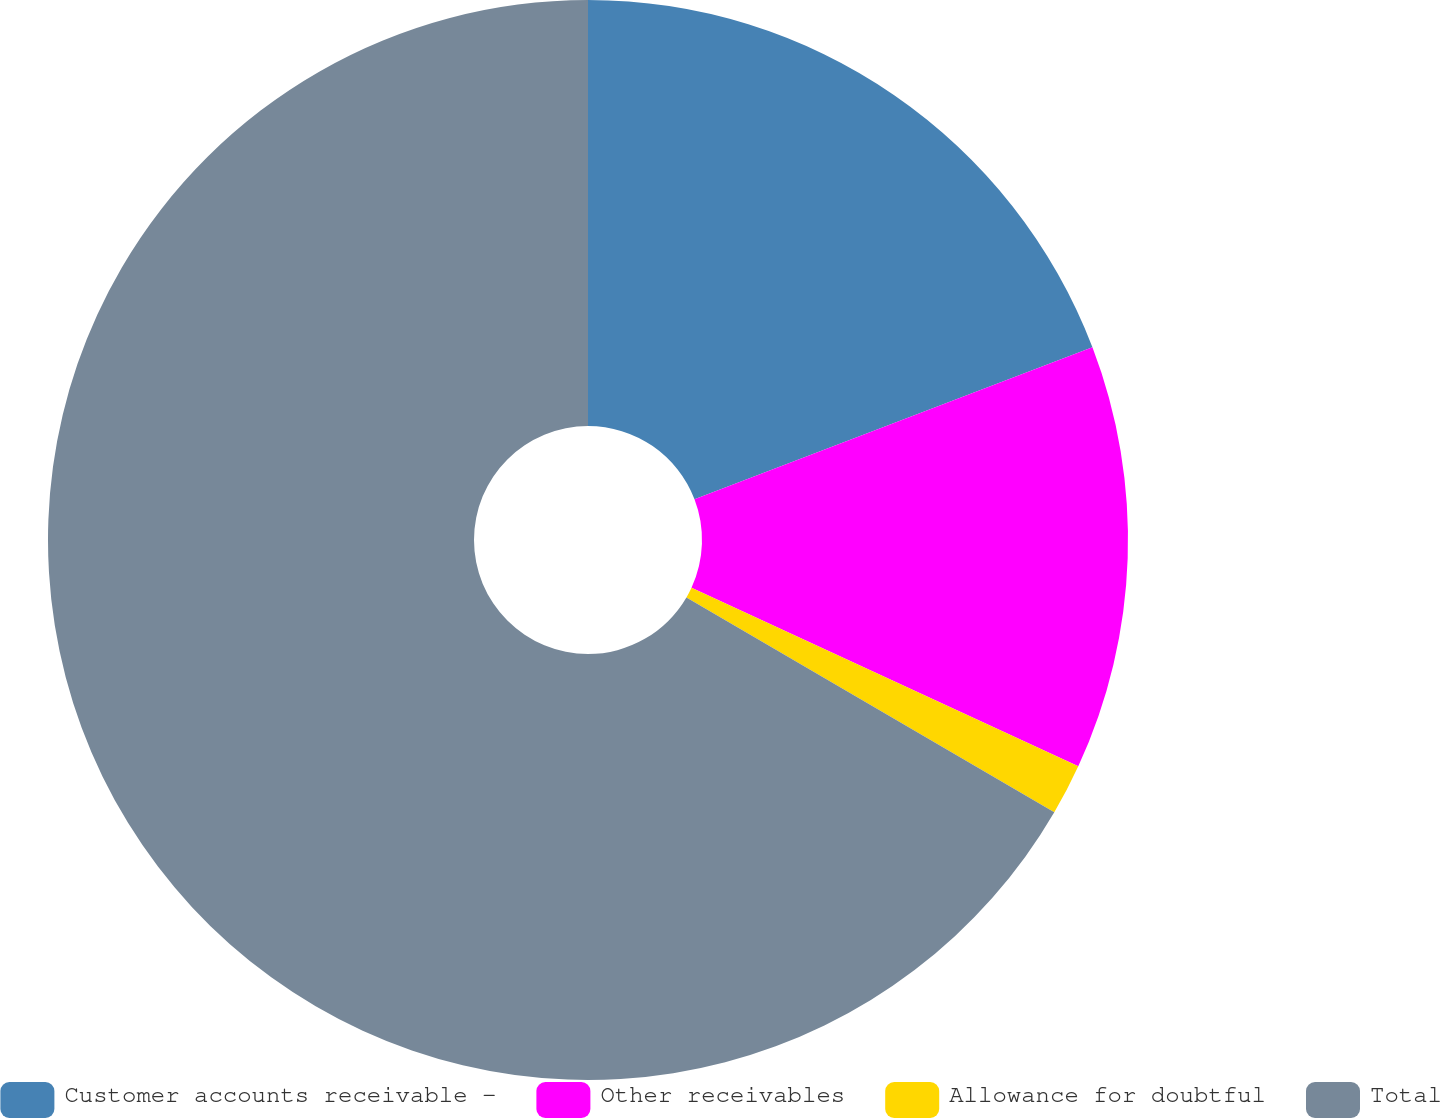<chart> <loc_0><loc_0><loc_500><loc_500><pie_chart><fcel>Customer accounts receivable -<fcel>Other receivables<fcel>Allowance for doubtful<fcel>Total<nl><fcel>19.19%<fcel>12.69%<fcel>1.53%<fcel>66.58%<nl></chart> 